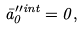Convert formula to latex. <formula><loc_0><loc_0><loc_500><loc_500>\bar { a } _ { 0 } ^ { \prime \prime i n t } = 0 ,</formula> 